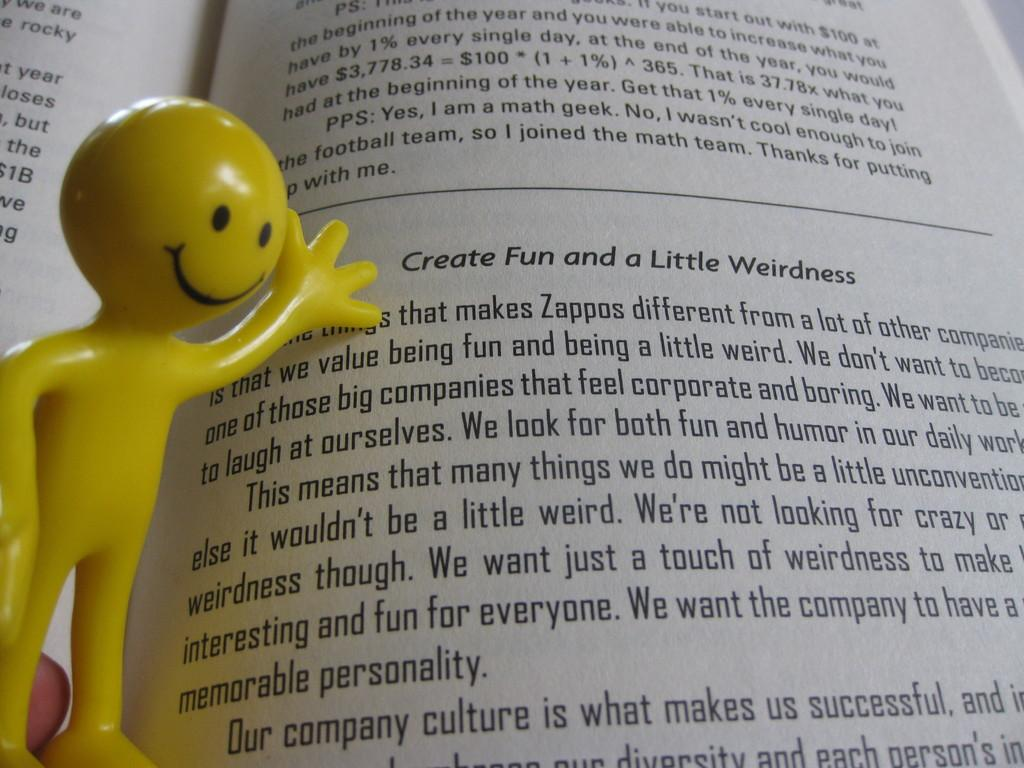What object can be seen in the image that contains written information? There is a book in the image that contains text. Can you describe the book in the image? The book has visible text on it. What other object is present on the left side of the image? There is a doll on the left side of the image. What color is the doll in the image? The doll is in yellow color. Is there a map in the image that the doll is using to navigate? There is no map present in the image, and the doll is not shown using any navigational tools. 